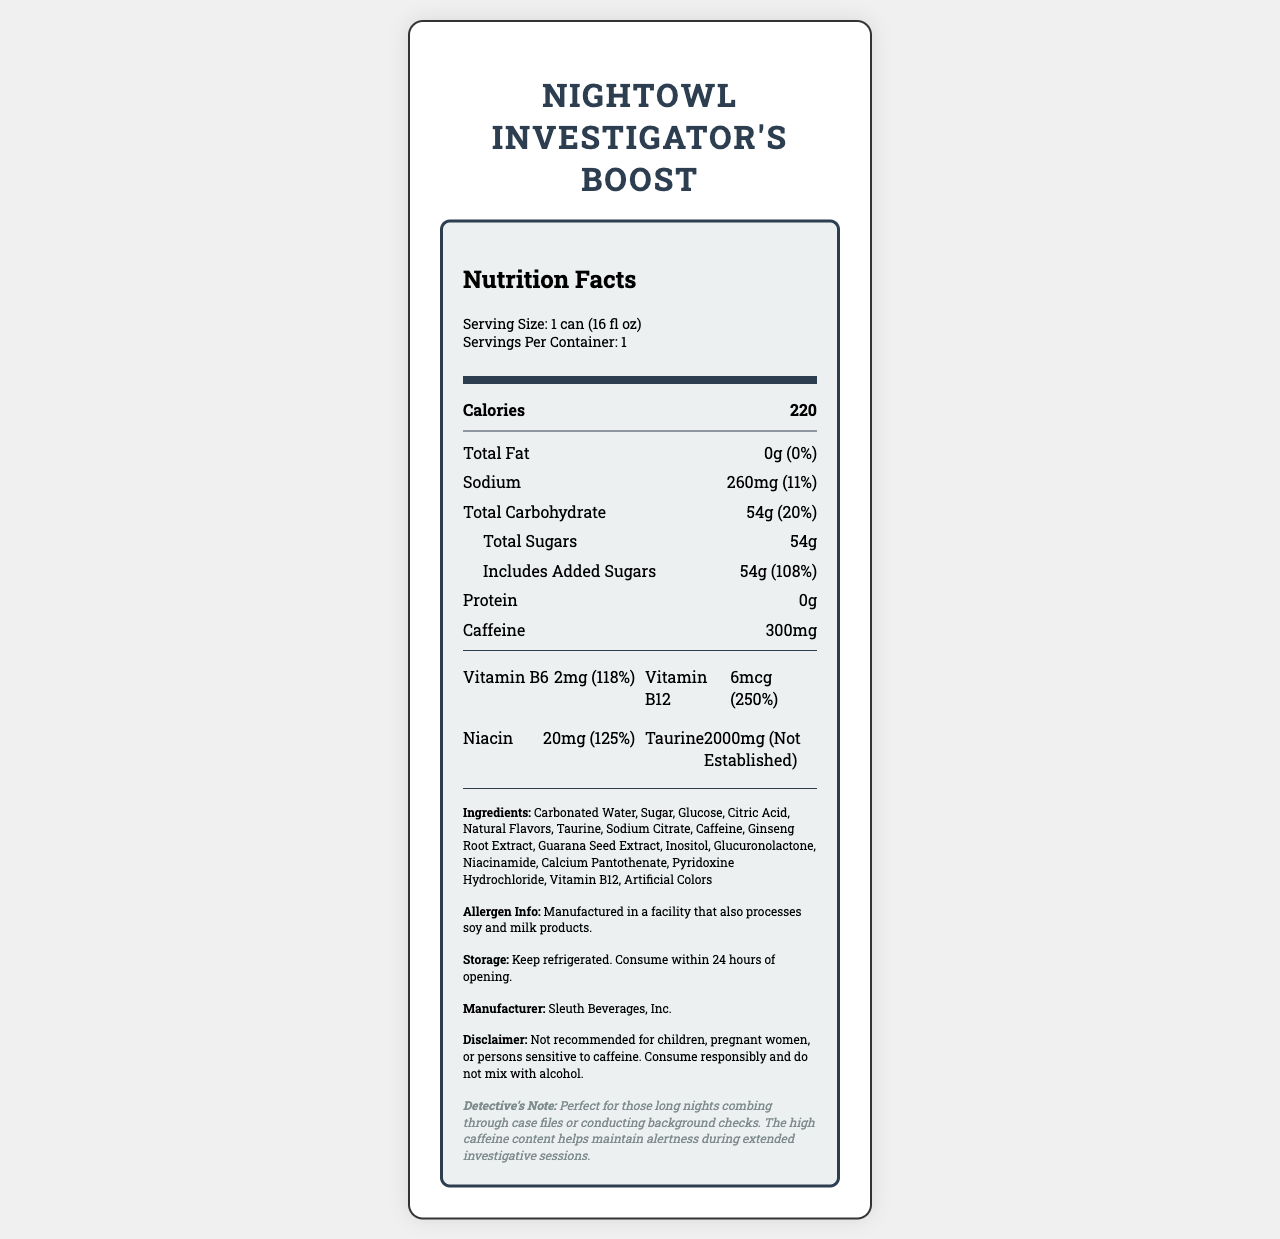what is the product's name? The product's name is clearly mentioned at the top of the document.
Answer: NightOwl Investigator's Boost what is the serving size of this energy drink? The serving size is specified in the serving info section.
Answer: 1 can (16 fl oz) how many calories are there per serving? The calorie count per serving is listed under the "Calories" section.
Answer: 220 what is the total carbohydrate content? Total carbohydrates, including the daily value percentage, are mentioned under the nutritional components.
Answer: 54g (20%) how much caffeine is in one serving? The caffeine amount per serving is listed in the nutritional information.
Answer: 300mg which vitamin has the highest daily value percentage? A. Vitamin B6 B. Vitamin B12 C. Niacin Vitamin B12 has a daily value percentage of 250%, which is the highest among the vitamins listed.
Answer: B. Vitamin B12 how much added sugar is in the drink? The added sugars amount and its daily value percentage are indicated under "Total Sugars."
Answer: 54g (108%) does the product contain any protein? The nutritional information shows that the protein content is 0g.
Answer: No is the product recommended for children? The disclaimer explicitly advises that the product is not recommended for children.
Answer: No where should the product be stored? The storage instructions specify that the product should be kept refrigerated.
Answer: Keep refrigerated does the energy drink contain any artificial colors? The list of ingredients includes "Artificial Colors."
Answer: Yes who is the manufacturer of this product? The manufacturer is mentioned at the bottom of the document.
Answer: Sleuth Beverages, Inc. what is the sodium content of this energy drink? The sodium content and its daily value percentage are listed in the nutritional information.
Answer: 260mg (11%) describe the detective's note. The detective's note emphasizes the suitability of the drink for long investigative sessions due to its high caffeine content, which aids in maintaining alertness.
Answer: Perfect for those long nights combing through case files or conducting background checks. The high caffeine content helps maintain alertness during extended investigative sessions. what are the natural flavors in the drink? The document lists "Natural Flavors" as an ingredient but does not specify what those flavors are.
Answer: I don't know summarize the main idea of the document. The summary includes an overview of the product's nutritional facts, ingredients, usage instructions, and special notes for its target audience.
Answer: The document provides detailed nutritional information for "NightOwl Investigator's Boost," a caffeine-rich energy drink designed for night shift workers like investigators and background check specialists. It includes serving size, calorie count, macronutrient content, vitamins and minerals, ingredients, allergen info, storage instructions, manufacturer details, and a disclaimer about consumption. The detective's note highlights the product's effectiveness for long working hours. 